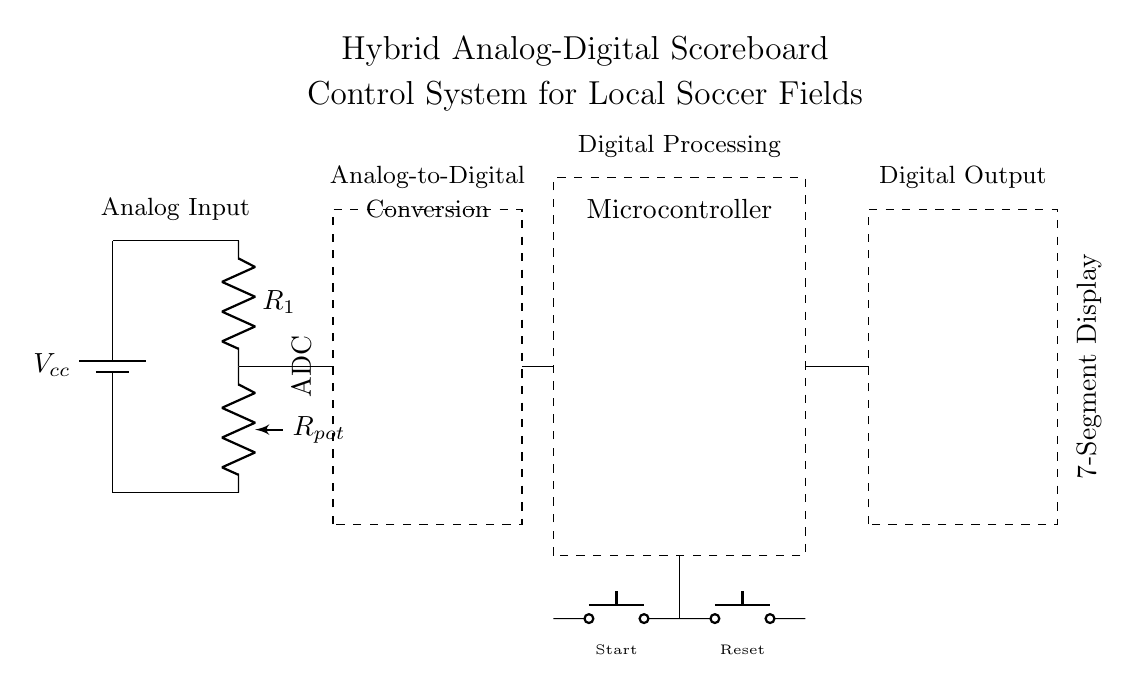What is the function of the potentiometer? The potentiometer acts as a variable resistor, allowing the user to adjust resistance and thus vary the analog input signal level.
Answer: variable resistor What does ADC stand for? ADC stands for Analog-to-Digital Converter, which converts the analog signals to digital data for processing.
Answer: Analog-to-Digital Converter How many buttons are present in the circuit? There are two push buttons in the circuit labeled as Start and Reset.
Answer: two What type of display is used in this hybrid scoreboard system? The display used is a 7-Segment Display, commonly used for displaying numerals.
Answer: 7-Segment Display What is the primary voltage supply indicated in the circuit? The primary voltage supply indicated in the circuit is labeled as Vcc.
Answer: Vcc Which component processes the digital signals? The Microcontroller processes the digital signals received from the ADC.
Answer: Microcontroller Why is there a dashed rectangle around the ADC? The dashed rectangle indicates that the ADC is a separate unit or module within the circuit design, delineating its boundaries from other components.
Answer: separate unit 